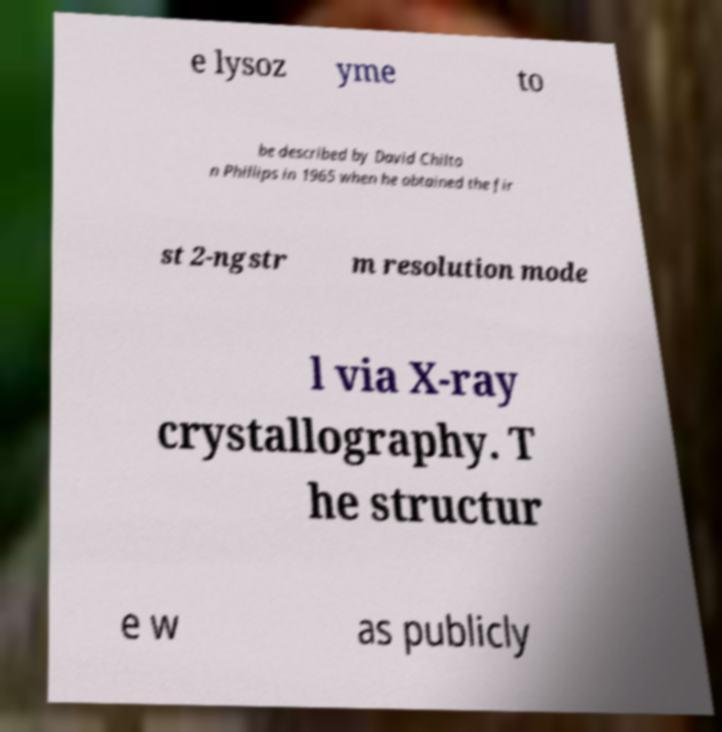Can you accurately transcribe the text from the provided image for me? e lysoz yme to be described by David Chilto n Phillips in 1965 when he obtained the fir st 2-ngstr m resolution mode l via X-ray crystallography. T he structur e w as publicly 